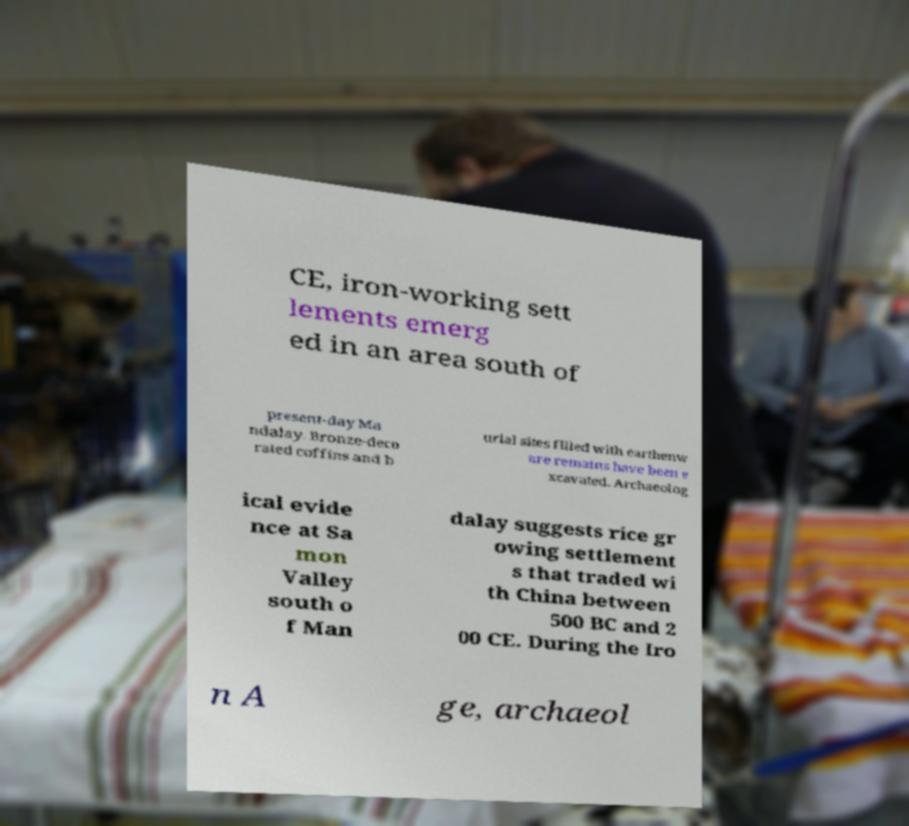What messages or text are displayed in this image? I need them in a readable, typed format. CE, iron-working sett lements emerg ed in an area south of present-day Ma ndalay. Bronze-deco rated coffins and b urial sites filled with earthenw are remains have been e xcavated. Archaeolog ical evide nce at Sa mon Valley south o f Man dalay suggests rice gr owing settlement s that traded wi th China between 500 BC and 2 00 CE. During the Iro n A ge, archaeol 